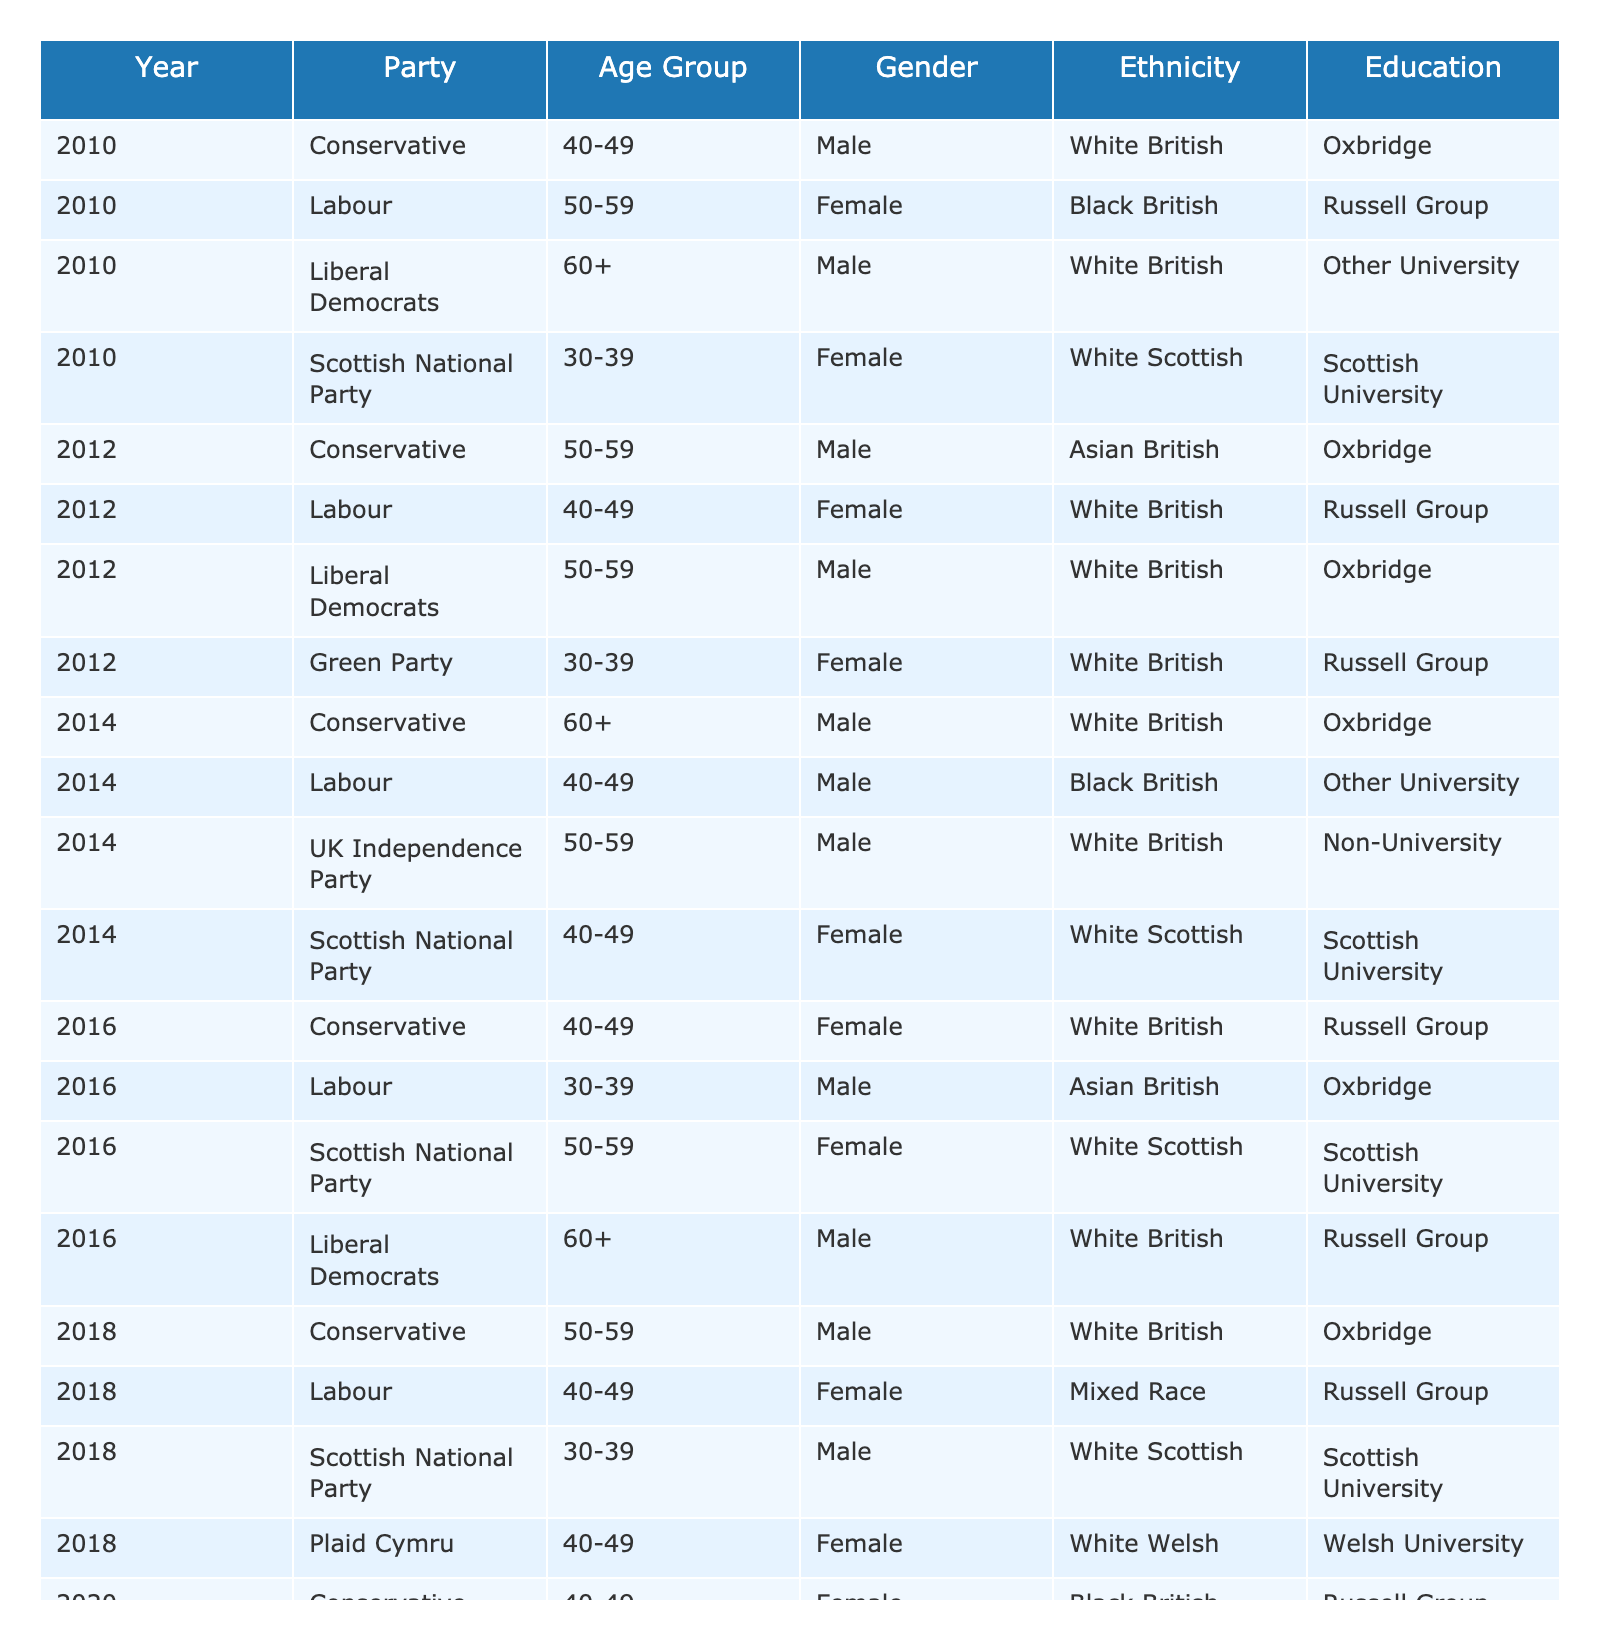What party had the most female members in 2018? In 2018, Conservative, Labour, Scottish National Party, and Plaid Cymru had female members. Counting the females, Conservative had 1, Labour had 1, SNP had 1, and Plaid Cymru had 1 female. There is no clear majority; they are all tied.
Answer: None Which age group had the most representatives from Labour in 2010? Reviewing the 2010 data, Labour had a representative in the 50-59 age group (1 member), while there were no other members listed from different age groups for Labour. Thus, the 50-59 age group had the most representatives from Labour in that year.
Answer: 50-59 Is there any Non-Binary representation in the table? The table includes one Non-Binary member in 2020 from the Green Party. This confirms that there is Non-Binary representation in the dataset.
Answer: Yes In which year did the Scottish National Party first have a representative from the 30-39 age group? The first occurrence of the Scottish National Party having a representative from the 30-39 age group is in 2018, where one male member is listed in this age group.
Answer: 2018 What is the percentage of Conservative members from the 40-49 age group across all years? There are three Conservative members from the 40-49 age group: one in 2010, one in 2016, and one in 2020, out of a total of 9 Conservative members (all years combined). To find the percentage: (3/9) * 100 = 33.33%.
Answer: 33.33% Did the representation of Asian British members increase from 2010 to 2016? In 2010, there were no Asian British members. In 2016, there was 1 Asian British male in Labour. Thus, there is an increase in representation from 0 to 1.
Answer: Yes What is the average age group of Liberal Democrat members in the dataset? The Liberal Democrats had representatives in several age groups: 60+ in 2010, 50-59 in 2012, and 60+ in 2016. To find the average, we convert age groups to numerical values (60+ = 65, 50-59 = 54.5), calculate the mean: (65 + 54.5 + 65) / 3 = 61.83.
Answer: 61.83 How many members from the Green Party are in the 30-39 age group across all years? The table indicates there is one Green Party member in the 30-39 age group in 2016, and one in the same age group in 2020. Therefore, there are 2 members.
Answer: 2 Was there a year when the majority of Conservative members were of the same gender? In 2014 and 2018, all Conservative members were male. Across those years, the gender representation is the same. Therefore, yes, there were years when the majority were of the same gender.
Answer: Yes How many unique ethnicities are represented in the data? By checking the dataset for all listed ethnicities (White British, Black British, Asian British, White Scottish, Mixed Race, and Non-Binary), we find a total of 6 unique ethnicities represented.
Answer: 6 